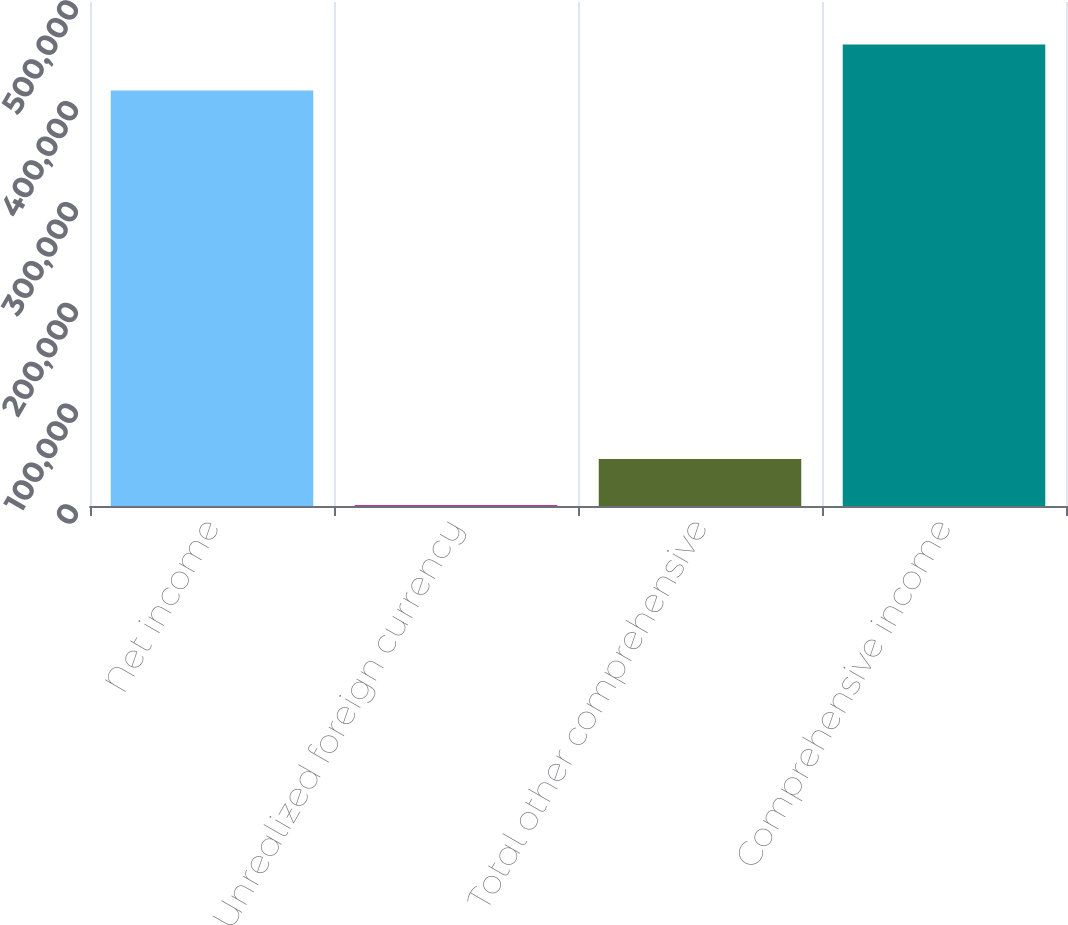Convert chart. <chart><loc_0><loc_0><loc_500><loc_500><bar_chart><fcel>Net income<fcel>Unrealized foreign currency<fcel>Total other comprehensive<fcel>Comprehensive income<nl><fcel>412106<fcel>877<fcel>46563.4<fcel>457792<nl></chart> 